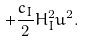<formula> <loc_0><loc_0><loc_500><loc_500>+ \frac { c _ { I } } { 2 } H ^ { 2 } _ { I } u ^ { 2 } .</formula> 